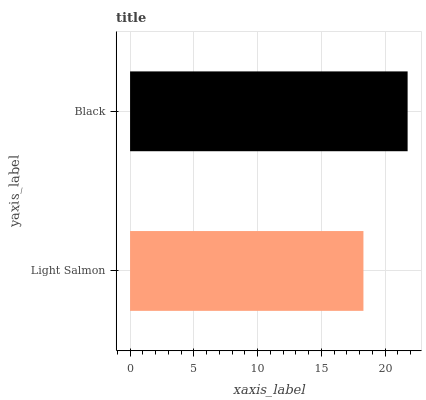Is Light Salmon the minimum?
Answer yes or no. Yes. Is Black the maximum?
Answer yes or no. Yes. Is Black the minimum?
Answer yes or no. No. Is Black greater than Light Salmon?
Answer yes or no. Yes. Is Light Salmon less than Black?
Answer yes or no. Yes. Is Light Salmon greater than Black?
Answer yes or no. No. Is Black less than Light Salmon?
Answer yes or no. No. Is Black the high median?
Answer yes or no. Yes. Is Light Salmon the low median?
Answer yes or no. Yes. Is Light Salmon the high median?
Answer yes or no. No. Is Black the low median?
Answer yes or no. No. 